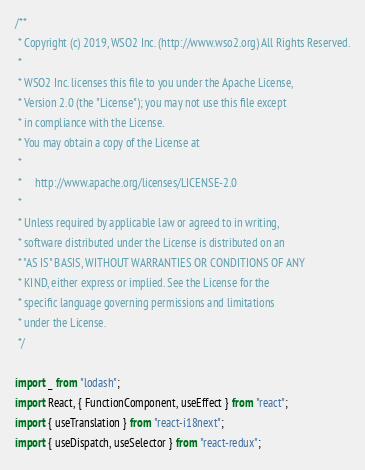Convert code to text. <code><loc_0><loc_0><loc_500><loc_500><_TypeScript_>/**
 * Copyright (c) 2019, WSO2 Inc. (http://www.wso2.org) All Rights Reserved.
 *
 * WSO2 Inc. licenses this file to you under the Apache License,
 * Version 2.0 (the "License"); you may not use this file except
 * in compliance with the License.
 * You may obtain a copy of the License at
 *
 *     http://www.apache.org/licenses/LICENSE-2.0
 *
 * Unless required by applicable law or agreed to in writing,
 * software distributed under the License is distributed on an
 * "AS IS" BASIS, WITHOUT WARRANTIES OR CONDITIONS OF ANY
 * KIND, either express or implied. See the License for the
 * specific language governing permissions and limitations
 * under the License.
 */

import _ from "lodash";
import React, { FunctionComponent, useEffect } from "react";
import { useTranslation } from "react-i18next";
import { useDispatch, useSelector } from "react-redux";</code> 